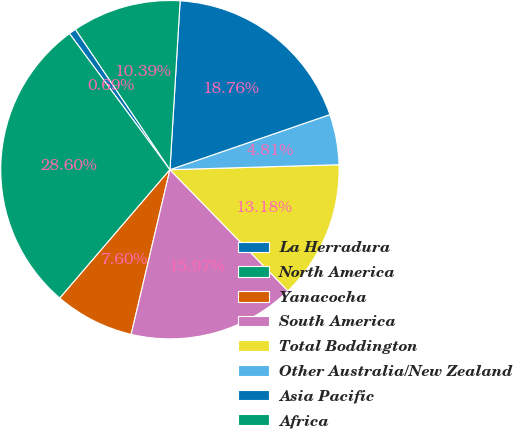Convert chart. <chart><loc_0><loc_0><loc_500><loc_500><pie_chart><fcel>La Herradura<fcel>North America<fcel>Yanacocha<fcel>South America<fcel>Total Boddington<fcel>Other Australia/New Zealand<fcel>Asia Pacific<fcel>Africa<nl><fcel>0.69%<fcel>28.6%<fcel>7.6%<fcel>15.97%<fcel>13.18%<fcel>4.81%<fcel>18.76%<fcel>10.39%<nl></chart> 